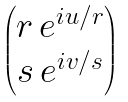<formula> <loc_0><loc_0><loc_500><loc_500>\begin{pmatrix} r \, e ^ { i u / r } \\ s \, e ^ { i v / s } \end{pmatrix}</formula> 